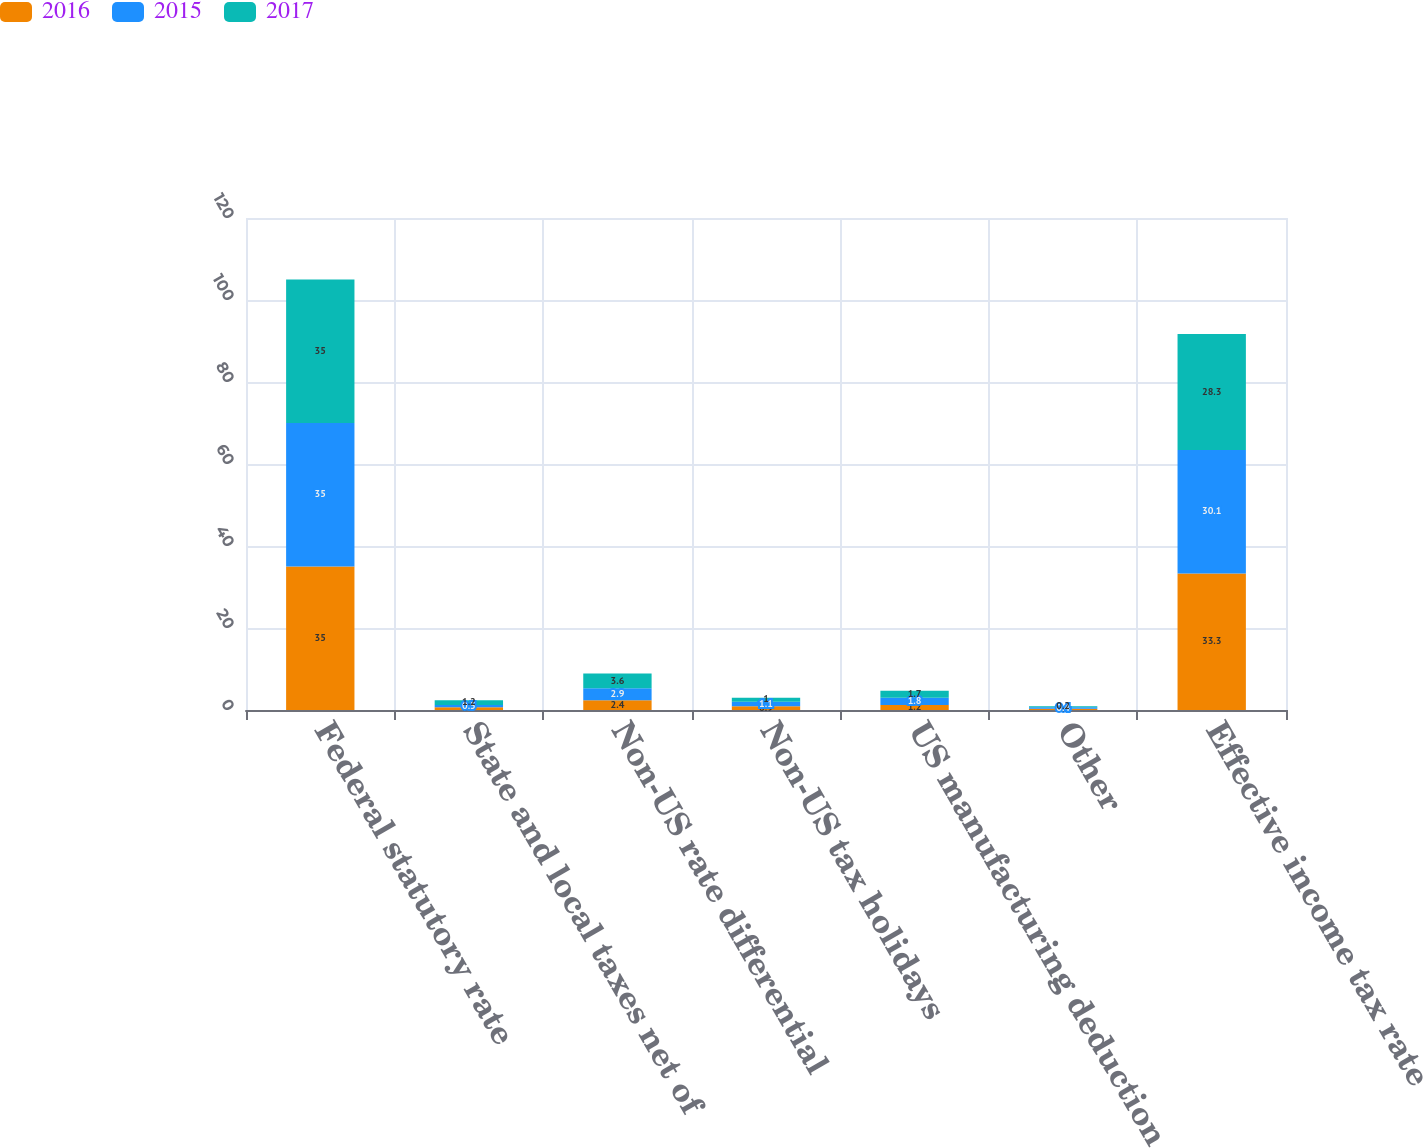Convert chart to OTSL. <chart><loc_0><loc_0><loc_500><loc_500><stacked_bar_chart><ecel><fcel>Federal statutory rate<fcel>State and local taxes net of<fcel>Non-US rate differential<fcel>Non-US tax holidays<fcel>US manufacturing deduction<fcel>Other<fcel>Effective income tax rate<nl><fcel>2016<fcel>35<fcel>0.7<fcel>2.4<fcel>0.9<fcel>1.2<fcel>0.3<fcel>33.3<nl><fcel>2015<fcel>35<fcel>0.5<fcel>2.9<fcel>1.1<fcel>1.8<fcel>0.4<fcel>30.1<nl><fcel>2017<fcel>35<fcel>1.2<fcel>3.6<fcel>1<fcel>1.7<fcel>0.2<fcel>28.3<nl></chart> 